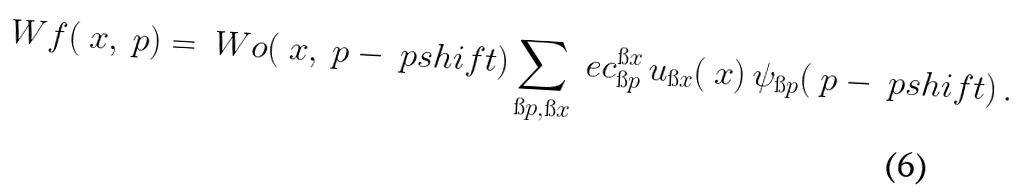Convert formula to latex. <formula><loc_0><loc_0><loc_500><loc_500>\ W f ( \ x , \ p ) = \ W o ( \ x , \ p - \ p s h i f t ) \sum _ { \i p , \i x } \ e c _ { \i p } ^ { \i x } \, u _ { \i x } ( \ x ) \, \psi _ { \i p } ( \ p - \ p s h i f t ) \, .</formula> 